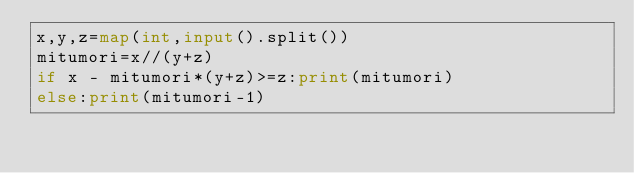Convert code to text. <code><loc_0><loc_0><loc_500><loc_500><_Python_>x,y,z=map(int,input().split())
mitumori=x//(y+z)
if x - mitumori*(y+z)>=z:print(mitumori)
else:print(mitumori-1)
</code> 